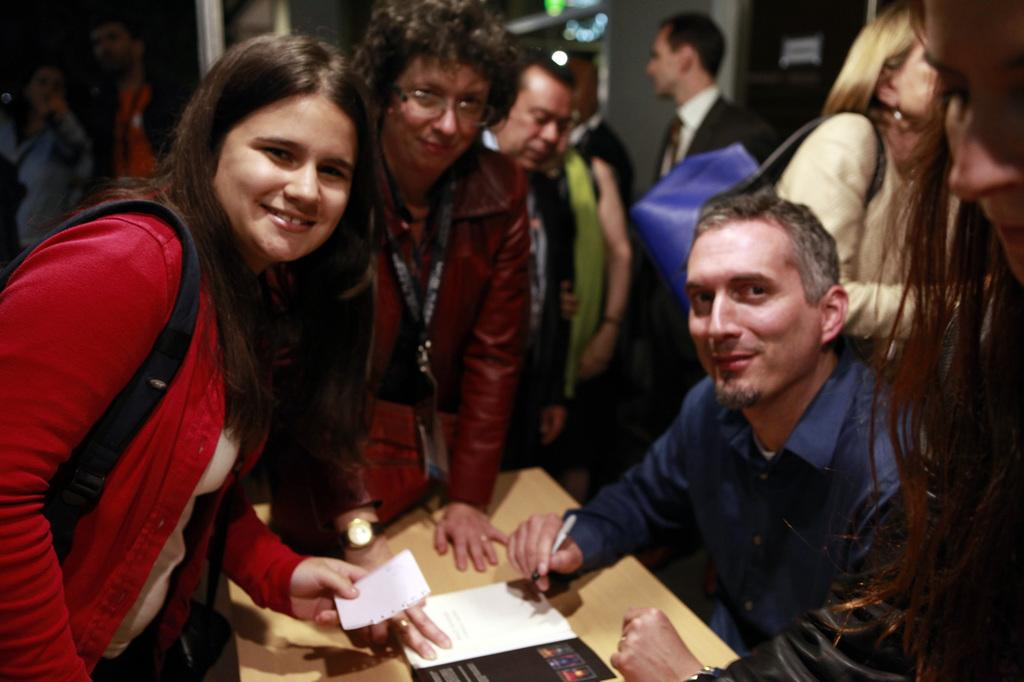How many people are in the image? There is a group of people in the image. Can you describe the person who is wearing a bag? The person with the bag is holding a paper. What is the person in front doing? The person in front is holding a pen. What object can be seen on the brown table? There is a book on a brown table. What type of theory can be seen floating down the river in the image? There is no river or theory present in the image. What is the group of people eating for breakfast in the image? There is no mention of breakfast or food in the image. 